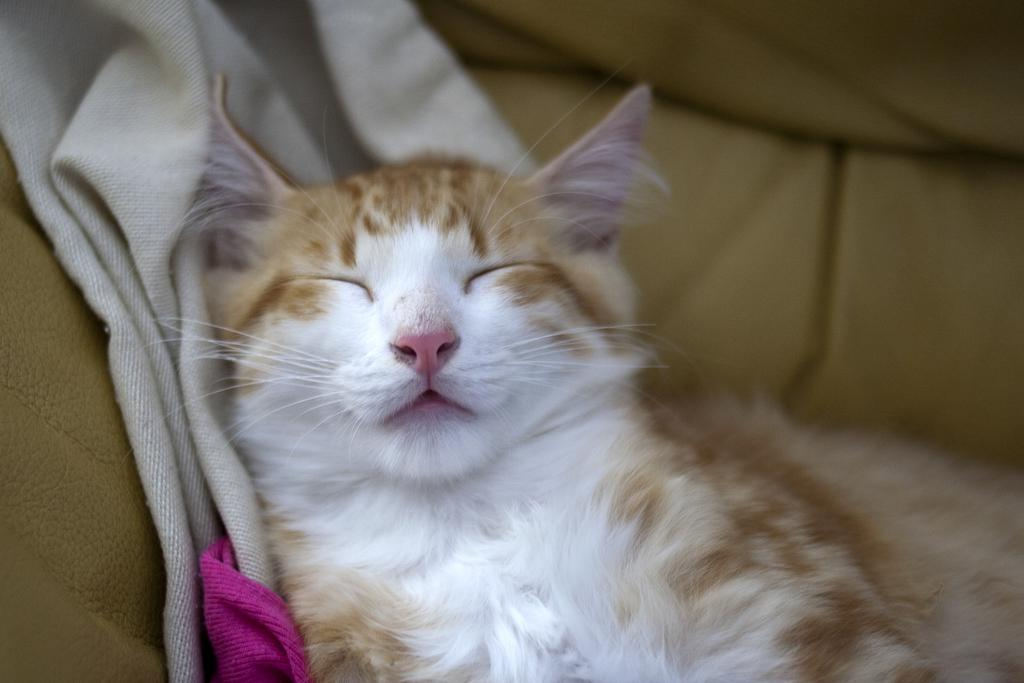What type of animal is in the image? There is a cat in the image. What is the cat doing in the image? The cat is sleeping. What else can be seen in the image besides the cat? There is a cloth visible in the image. What type of cave can be seen in the background of the image? There is no cave present in the image; it features a cat sleeping and a cloth. 